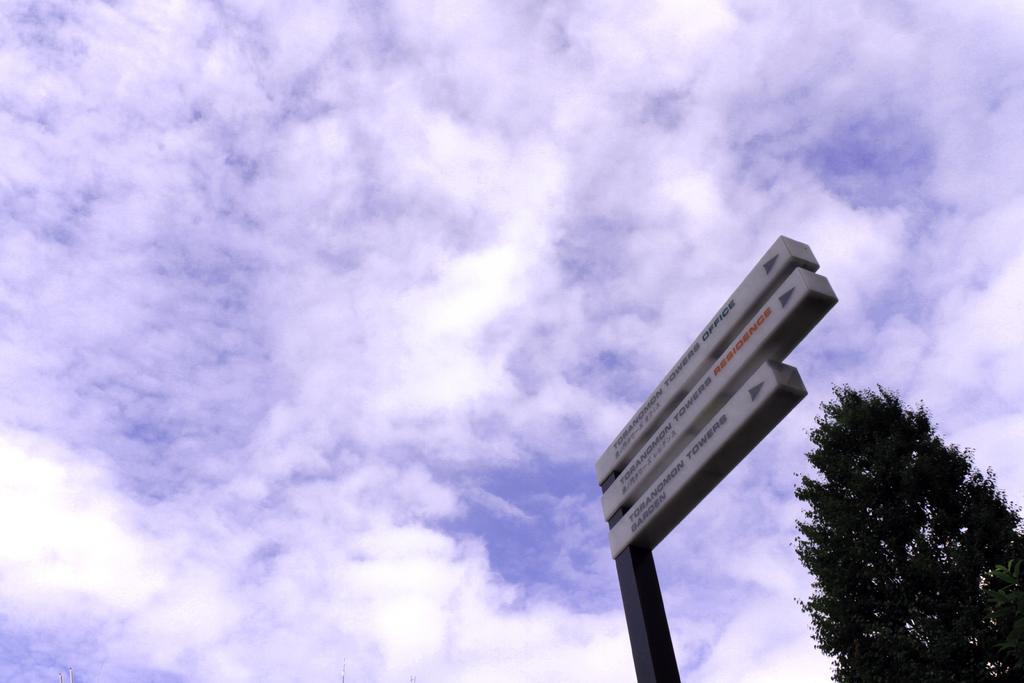What object can be seen attached to a pole in the image? There is a street sign in the image that is attached to a pole. What else is present in the image besides the street sign? There is a tree in the image. What part of the natural environment is visible in the image? The sky is visible in the image. How would you describe the sky in the image? The sky appears to be cloudy in the image. What type of boat can be seen sailing in the image? There is no boat present in the image; it features a street sign, a tree, and a cloudy sky. 